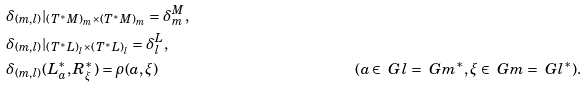<formula> <loc_0><loc_0><loc_500><loc_500>& \delta _ { ( m , l ) } | _ { ( T ^ { * } M ) _ { m } \times ( T ^ { * } M ) _ { m } } = \delta ^ { M } _ { m } , \\ & \delta _ { ( m , l ) } | _ { ( T ^ { * } L ) _ { l } \times ( T ^ { * } L ) _ { l } } = \delta ^ { L } _ { l } , \\ & \delta _ { ( m , l ) } ( L ^ { * } _ { a } , R ^ { * } _ { \xi } ) = \rho ( a , \xi ) & ( a \in \ G l = \ G m ^ { * } , \xi \in \ G m = \ G l ^ { * } ) .</formula> 